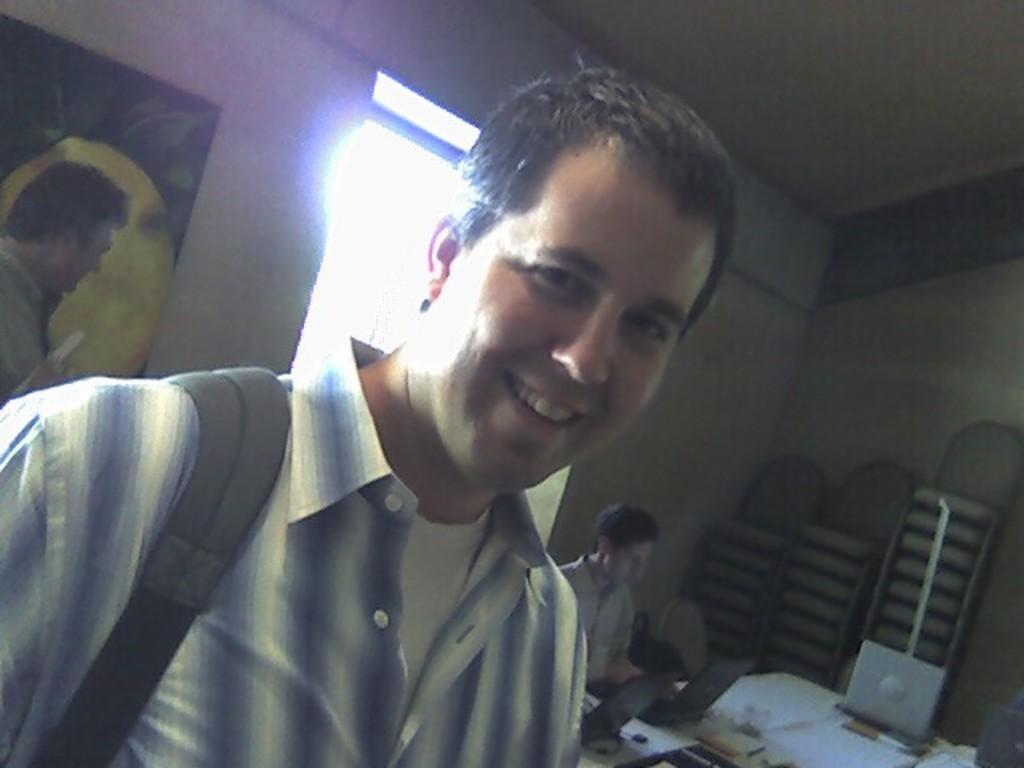In one or two sentences, can you explain what this image depicts? In the image there is a man wearing white and blue striped shirt smiling and behind him there is a person sitting in front of the table with laptops and books on it and behind him there is a window, on the left side there is a painting on the wall with a person standing in front of it. 